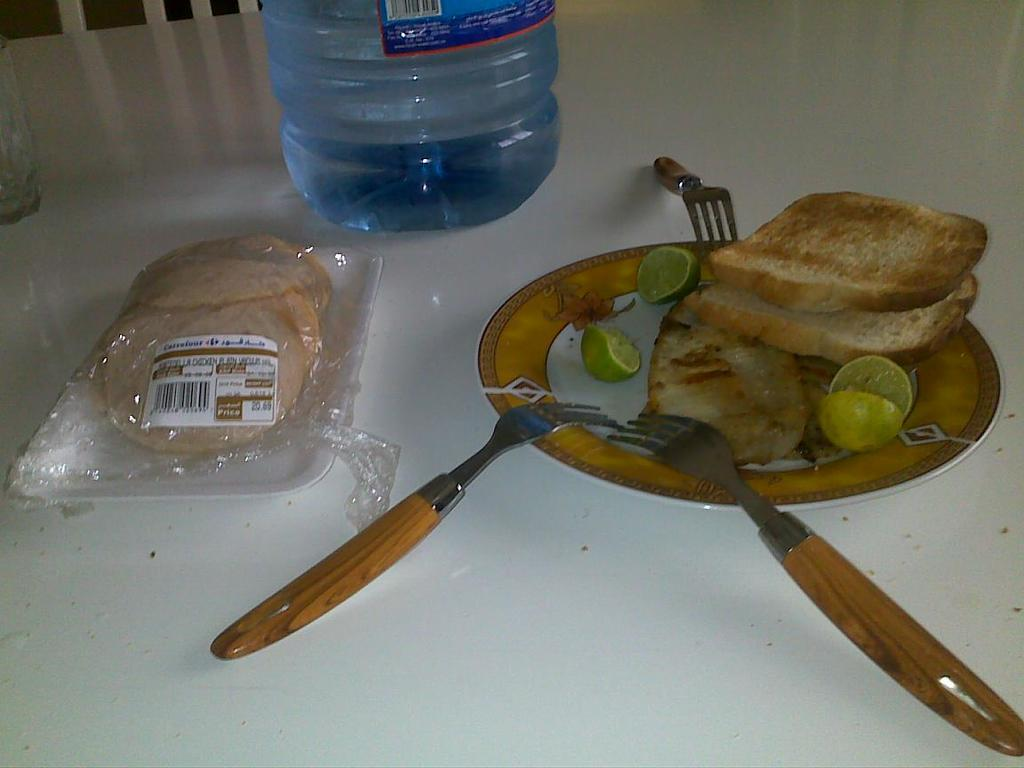What piece of furniture is present in the image? There is a table in the image. What is placed on the table? There is a plate on the table, with bread and a lemon on it. What utensil is present on the table? There is a fork on the table. What additional item is on the table? There is a tray on the table with food on it, and a water can. Can you describe the background of the image? There is a chair in the background of the image. How many bells are hanging from the chair in the image? There are no bells present in the image; the chair in the background does not have any bells hanging from it. 